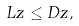<formula> <loc_0><loc_0><loc_500><loc_500>L z \leq D z ,</formula> 